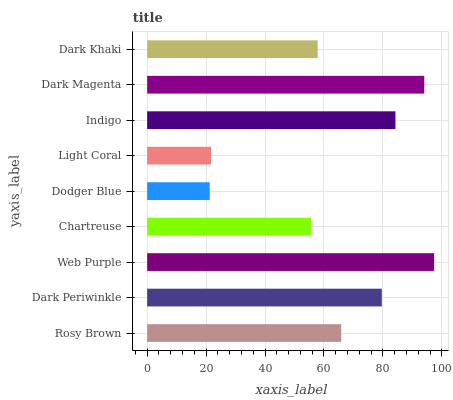Is Dodger Blue the minimum?
Answer yes or no. Yes. Is Web Purple the maximum?
Answer yes or no. Yes. Is Dark Periwinkle the minimum?
Answer yes or no. No. Is Dark Periwinkle the maximum?
Answer yes or no. No. Is Dark Periwinkle greater than Rosy Brown?
Answer yes or no. Yes. Is Rosy Brown less than Dark Periwinkle?
Answer yes or no. Yes. Is Rosy Brown greater than Dark Periwinkle?
Answer yes or no. No. Is Dark Periwinkle less than Rosy Brown?
Answer yes or no. No. Is Rosy Brown the high median?
Answer yes or no. Yes. Is Rosy Brown the low median?
Answer yes or no. Yes. Is Dodger Blue the high median?
Answer yes or no. No. Is Dodger Blue the low median?
Answer yes or no. No. 